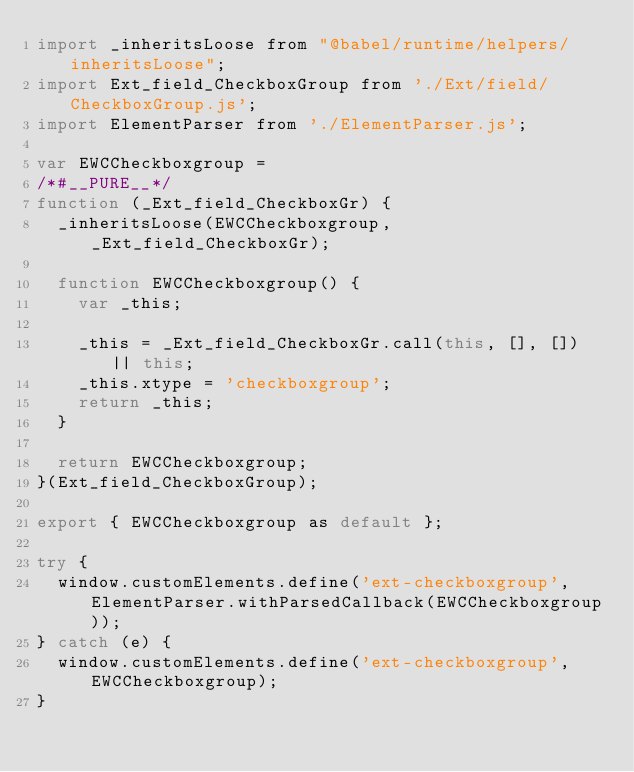<code> <loc_0><loc_0><loc_500><loc_500><_JavaScript_>import _inheritsLoose from "@babel/runtime/helpers/inheritsLoose";
import Ext_field_CheckboxGroup from './Ext/field/CheckboxGroup.js';
import ElementParser from './ElementParser.js';

var EWCCheckboxgroup =
/*#__PURE__*/
function (_Ext_field_CheckboxGr) {
  _inheritsLoose(EWCCheckboxgroup, _Ext_field_CheckboxGr);

  function EWCCheckboxgroup() {
    var _this;

    _this = _Ext_field_CheckboxGr.call(this, [], []) || this;
    _this.xtype = 'checkboxgroup';
    return _this;
  }

  return EWCCheckboxgroup;
}(Ext_field_CheckboxGroup);

export { EWCCheckboxgroup as default };

try {
  window.customElements.define('ext-checkboxgroup', ElementParser.withParsedCallback(EWCCheckboxgroup));
} catch (e) {
  window.customElements.define('ext-checkboxgroup', EWCCheckboxgroup);
}</code> 